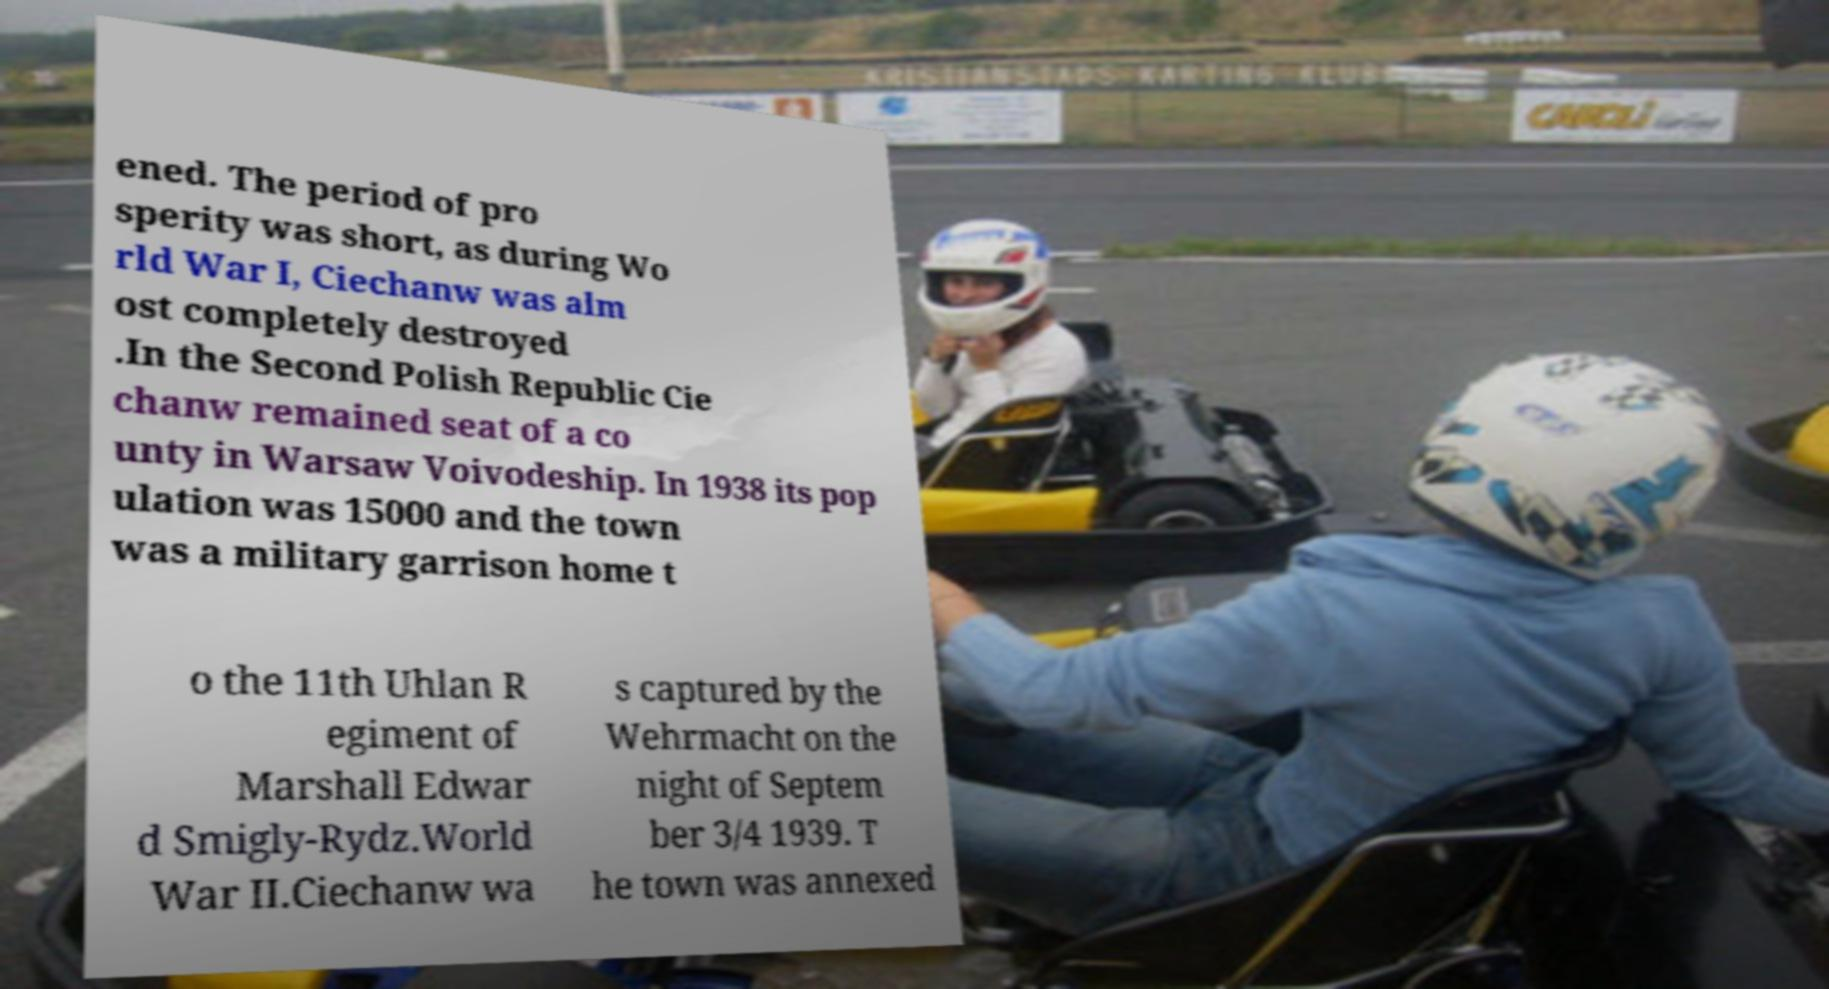Can you read and provide the text displayed in the image?This photo seems to have some interesting text. Can you extract and type it out for me? ened. The period of pro sperity was short, as during Wo rld War I, Ciechanw was alm ost completely destroyed .In the Second Polish Republic Cie chanw remained seat of a co unty in Warsaw Voivodeship. In 1938 its pop ulation was 15000 and the town was a military garrison home t o the 11th Uhlan R egiment of Marshall Edwar d Smigly-Rydz.World War II.Ciechanw wa s captured by the Wehrmacht on the night of Septem ber 3/4 1939. T he town was annexed 